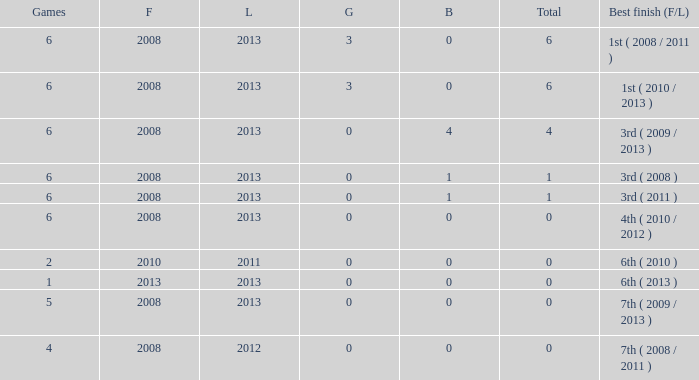What is the fewest number of medals associated with under 6 games and over 0 golds? None. 